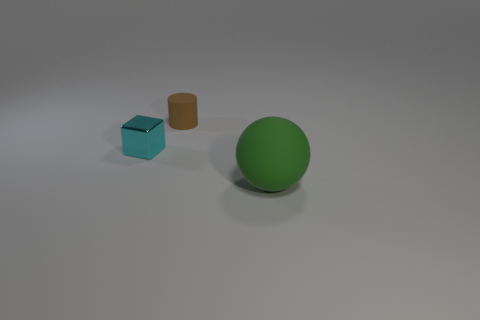Subtract all green cylinders. Subtract all purple balls. How many cylinders are left? 1 Add 3 small green matte things. How many objects exist? 6 Subtract all spheres. How many objects are left? 2 Add 2 cyan metallic cubes. How many cyan metallic cubes are left? 3 Add 3 small blue shiny balls. How many small blue shiny balls exist? 3 Subtract 0 green cylinders. How many objects are left? 3 Subtract all small brown things. Subtract all small cyan metal blocks. How many objects are left? 1 